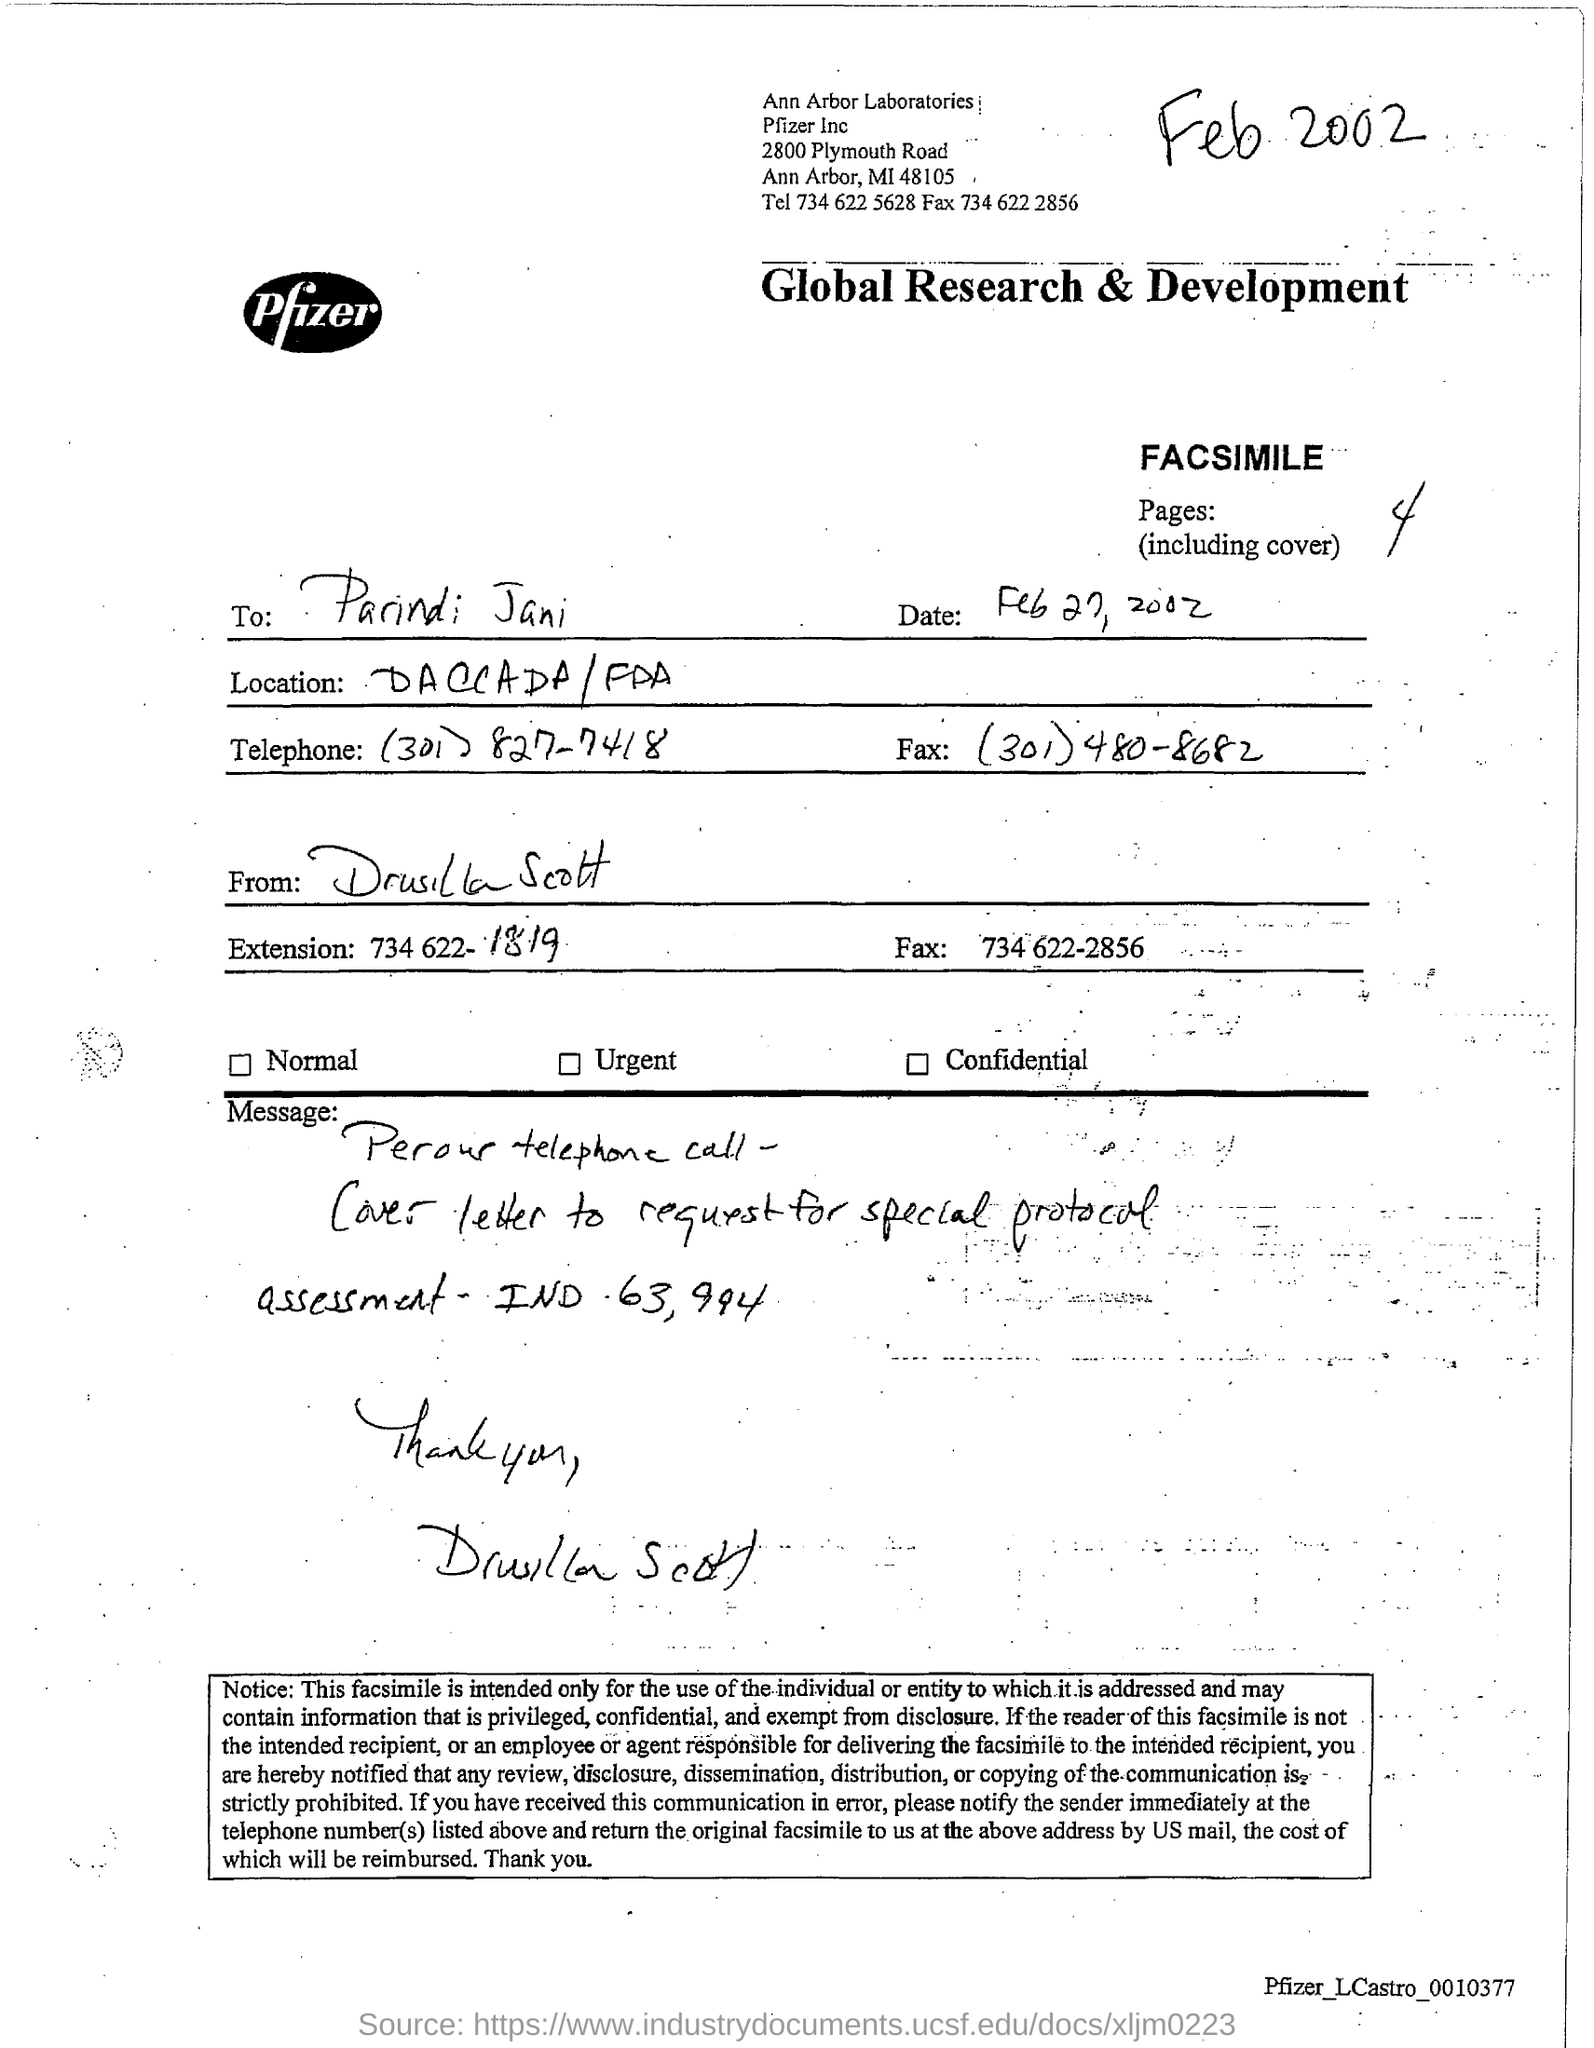Give some essential details in this illustration. The sender of the facsimile is Drusilla Scott. The facsimile contains 4 pages, including the cover. The fax number for Drusilla Scott is 734-622-2856. The fax number for Parindi Jani is (301) 480-8682. The facsimile is being sent to Parindi Jani. 